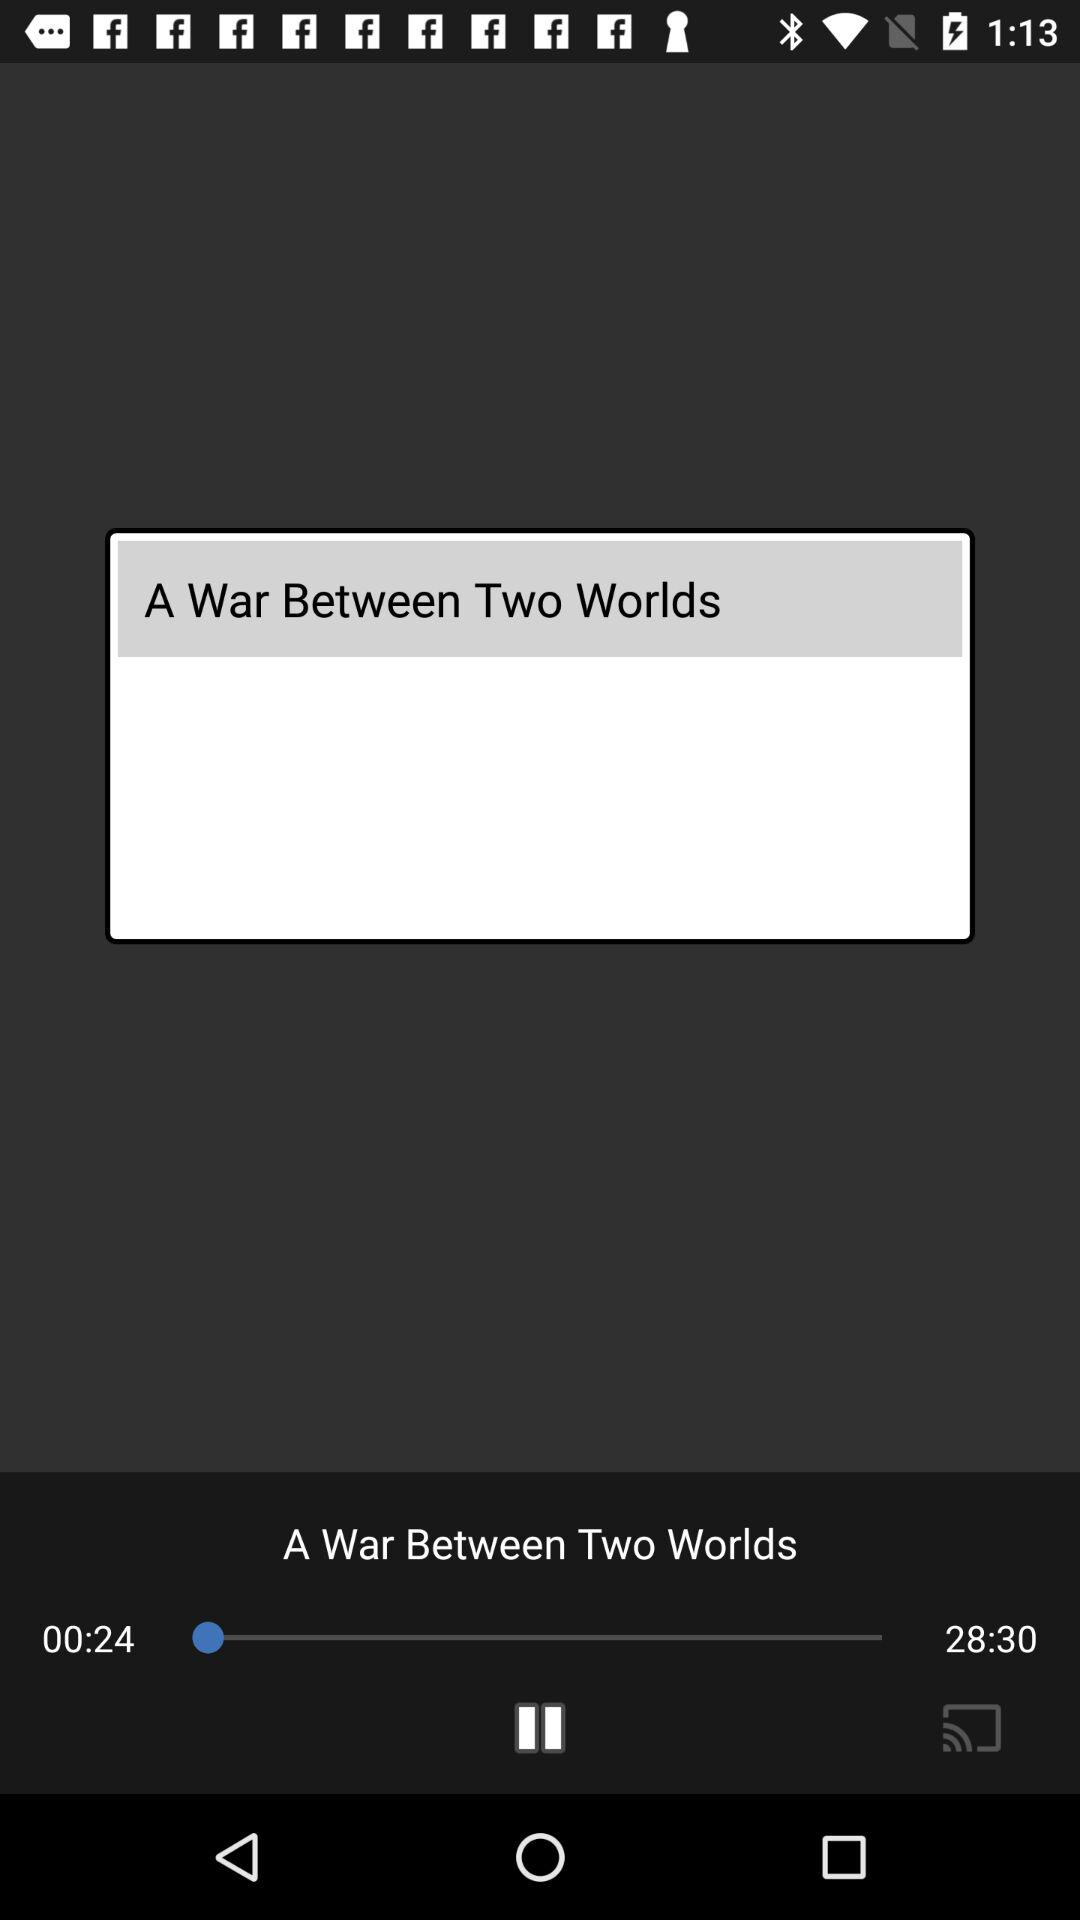What is the time duration of the audio "A War Between Two Worlds"? The time duration is 28 minutes 30 seconds. 